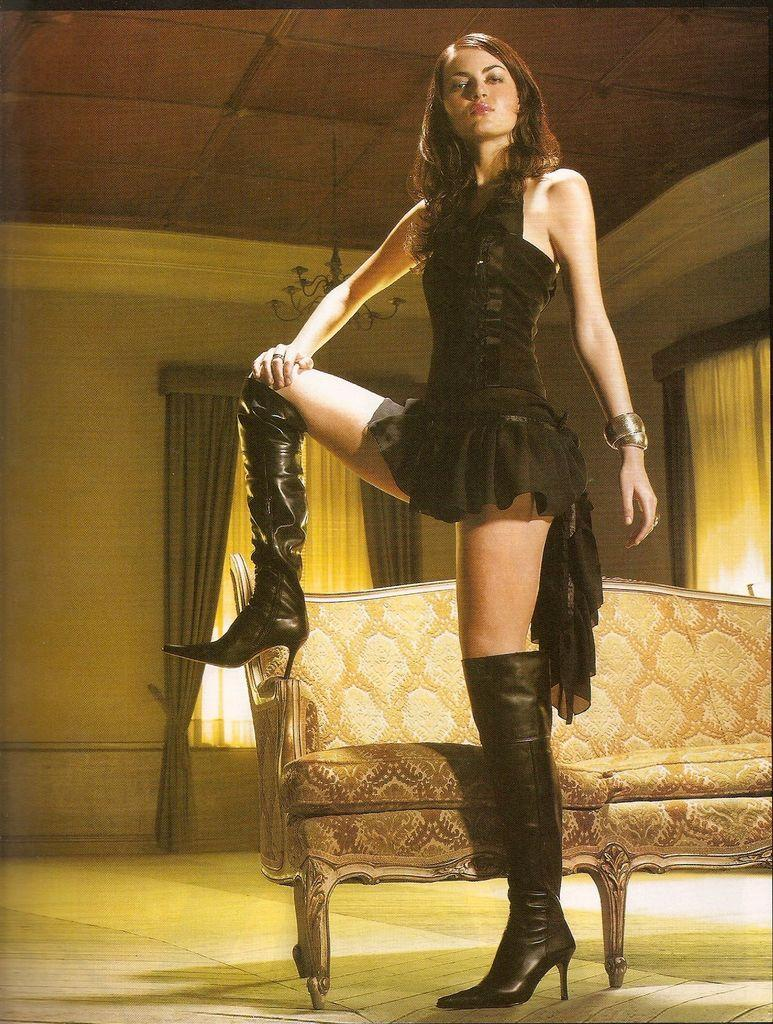Who is present in the image? There is a lady in the image. What is the lady wearing? The lady is wearing a black dress. What type of furniture can be seen in the image? There is a couch in the image. What architectural features are visible in the image? There are windows, curtains, hang lights, and walls in the image. What type of income does the lady in the image have? There is no information about the lady's income in the image. What caption is written on the image? There is no caption present in the image. 